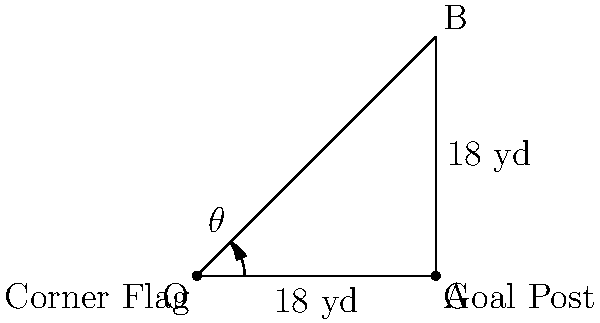During a corner kick for Atlanta United FC, the corner flag is at point O, and the nearest goal post is at point A. The penalty area extends 18 yards from the goal line in both directions. If the angle between the goal line and the direct path from the corner flag to the far post (point B) is $\theta$, what is the value of $\theta$ (in degrees, rounded to the nearest whole number)? Let's approach this step-by-step:

1) First, we need to recognize that we have a right-angled triangle OAB.

2) We know that the penalty area extends 18 yards in both directions, so:
   OA = 18 yards (along the goal line)
   AB = 18 yards (perpendicular to the goal line)

3) Now we can use the arctangent function to find the angle $\theta$:

   $\theta = \arctan(\frac{AB}{OA})$

4) Substituting the values:

   $\theta = \arctan(\frac{18}{18}) = \arctan(1)$

5) $\arctan(1)$ is equal to 45 degrees.

6) The question asks for the answer rounded to the nearest whole number, but 45 is already a whole number, so no rounding is necessary.
Answer: 45° 